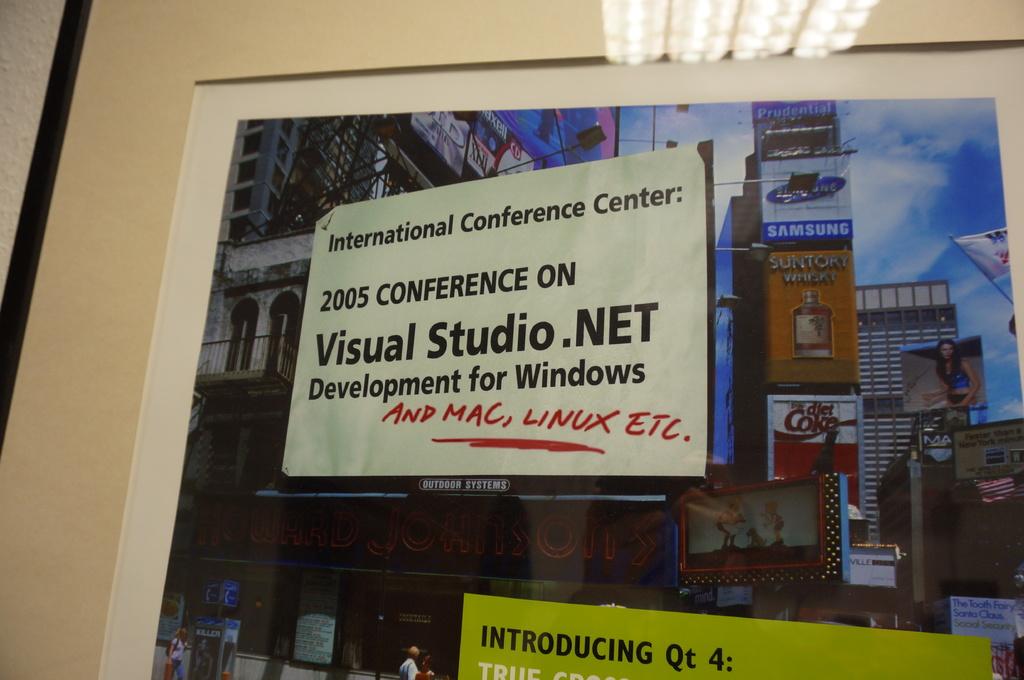What is the name of the center?
Your answer should be compact. International conference center. What year is cited on the sign?
Your answer should be compact. 2005. 